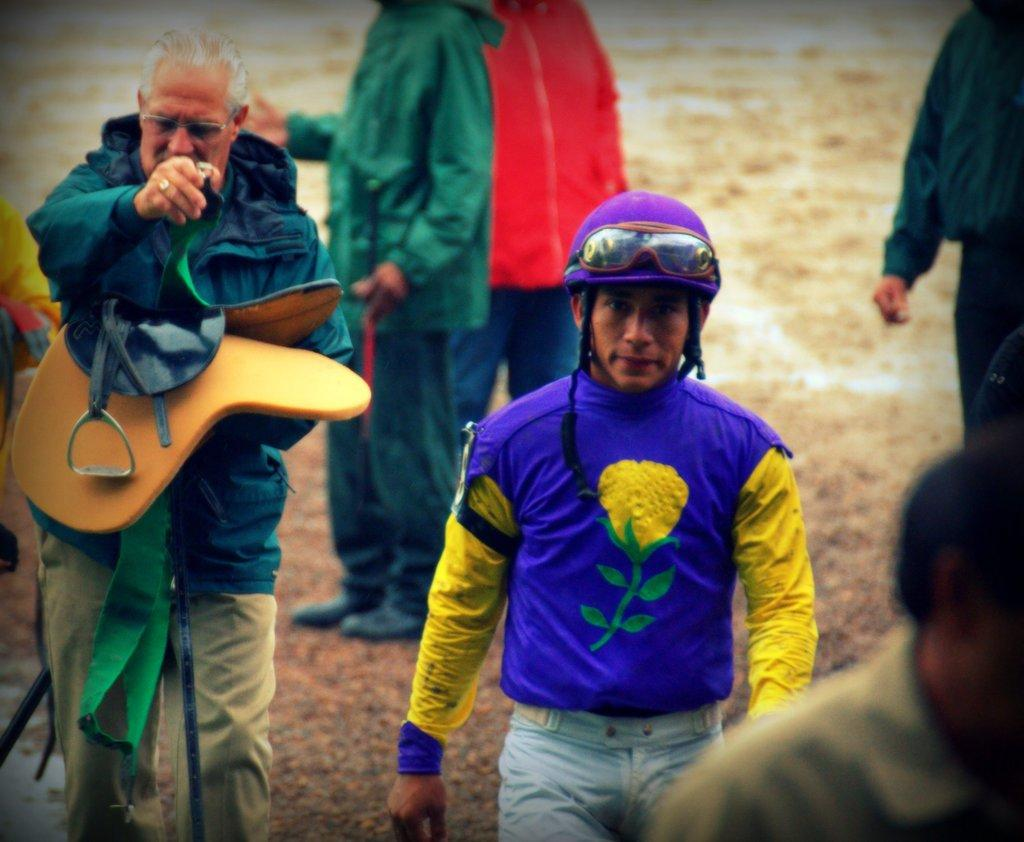Who or what is present in the image? There are people in the image. What are the people wearing? The people are wearing colorful dresses. Where are the people standing? The people are standing on the ground. What type of lead can be seen in the image? There is no lead present in the image. How many shoes are visible in the image? The provided facts do not mention shoes, so it cannot be determined how many are visible in the image. 